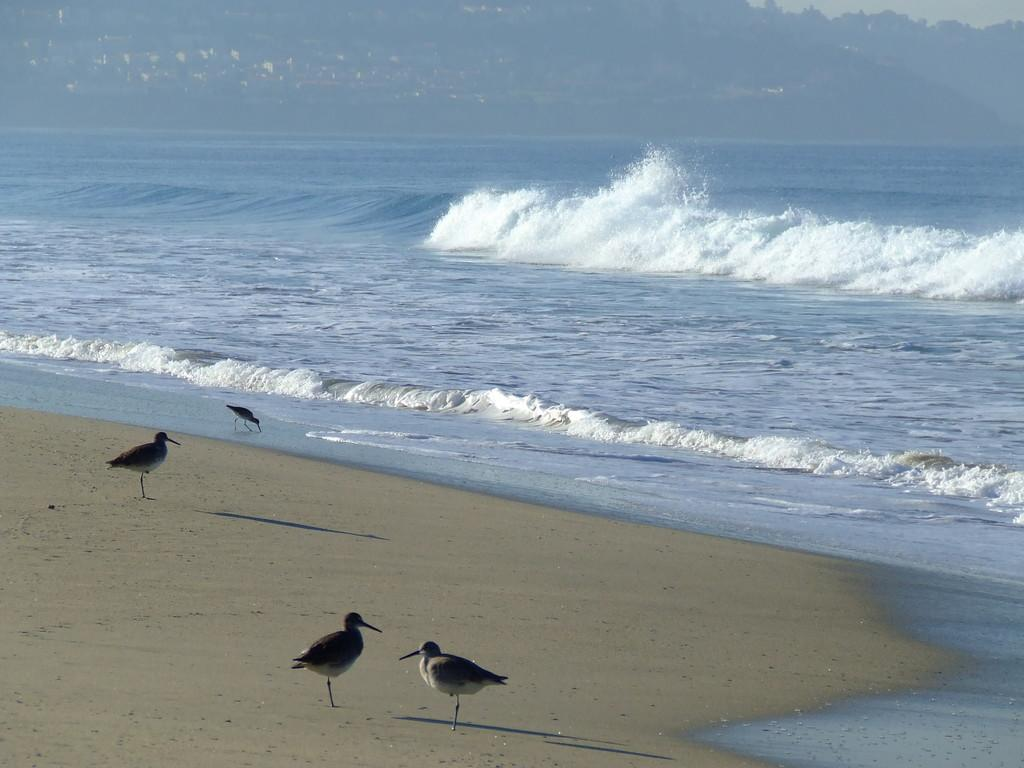What type of animals are at the bottom of the image? There are birds at the bottom of the image. What is located beneath the birds in the image? Soil is present at the bottom of the image. What can be seen in the background of the image? There is water visible in the background of the image. What type of landscape feature is at the top of the image? There are hills at the top of the image. What is visible above the hills in the image? The sky is visible at the top of the image. What type of silk is being produced by the birds in the image? There is no silk or bird-related silk production in the image; it features birds, soil, water, hills, and the sky. How does the digestion of the birds affect the water in the image? There is no indication of bird digestion or its effect on the water in the image. 